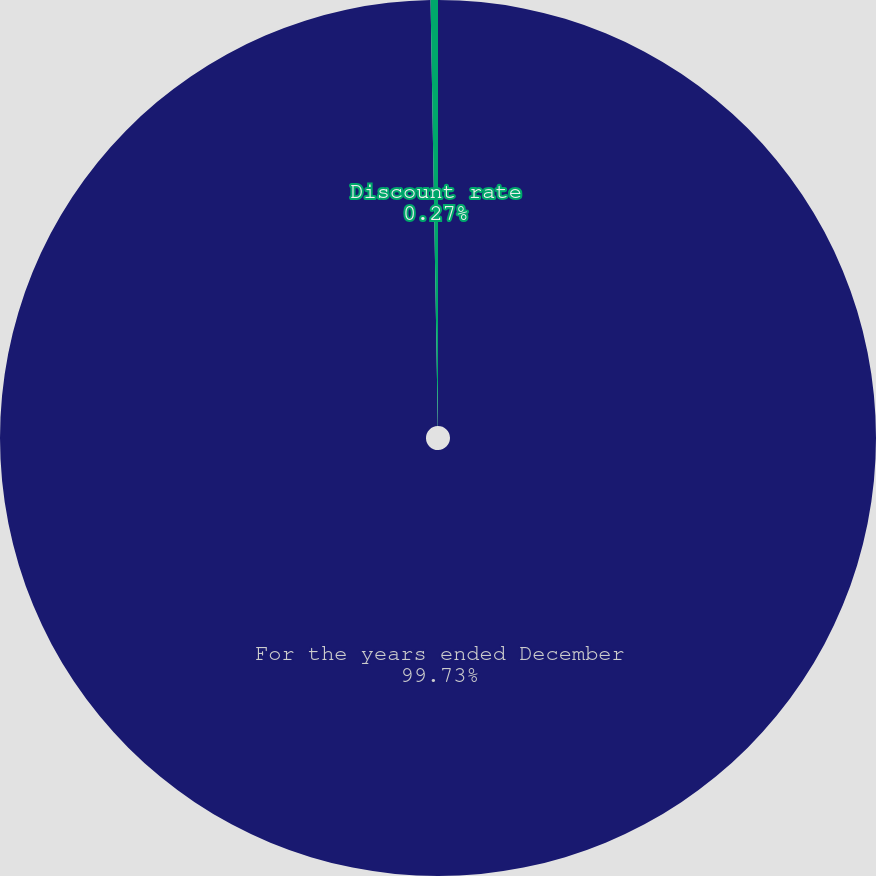<chart> <loc_0><loc_0><loc_500><loc_500><pie_chart><fcel>For the years ended December<fcel>Discount rate<nl><fcel>99.73%<fcel>0.27%<nl></chart> 